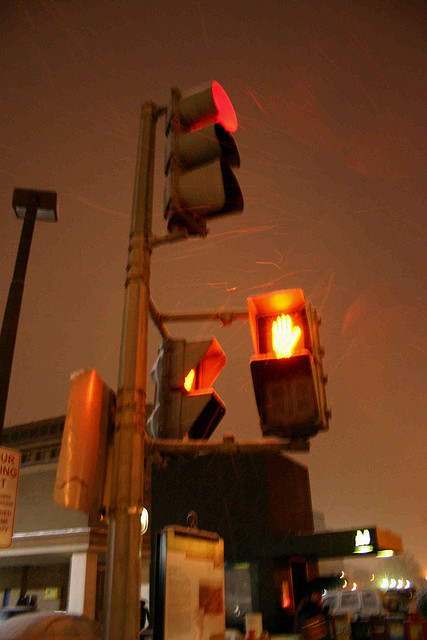What weather condition can be inferred from the image? The streaking lines suggest that it's raining, and the wetness on roads reflects the light, pointing to rainy weather conditions. Is this type of weather common for this location? Without specific location details, it's hard to say if it's common, but the presence of heavy traffic signals might suggest an area prepared for varying weather conditions. 